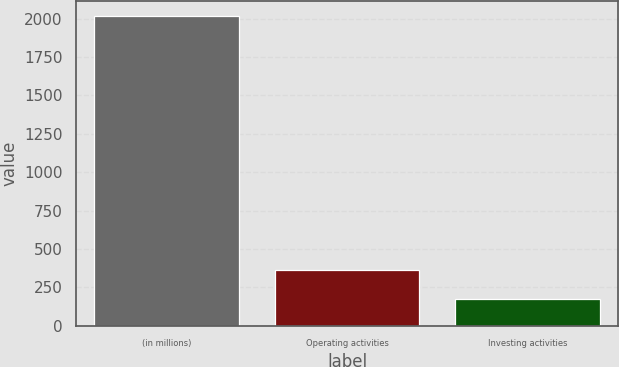<chart> <loc_0><loc_0><loc_500><loc_500><bar_chart><fcel>(in millions)<fcel>Operating activities<fcel>Investing activities<nl><fcel>2015<fcel>360.8<fcel>177<nl></chart> 